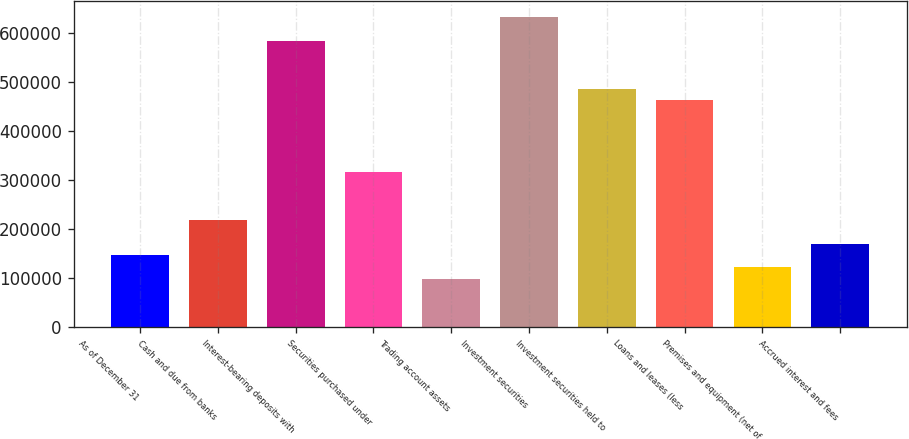<chart> <loc_0><loc_0><loc_500><loc_500><bar_chart><fcel>As of December 31<fcel>Cash and due from banks<fcel>Interest-bearing deposits with<fcel>Securities purchased under<fcel>Trading account assets<fcel>Investment securities<fcel>Investment securities held to<fcel>Loans and leases (less<fcel>Premises and equipment (net of<fcel>Accrued interest and fees<nl><fcel>145982<fcel>218964<fcel>583872<fcel>316273<fcel>97327.8<fcel>632526<fcel>486563<fcel>462236<fcel>121655<fcel>170309<nl></chart> 